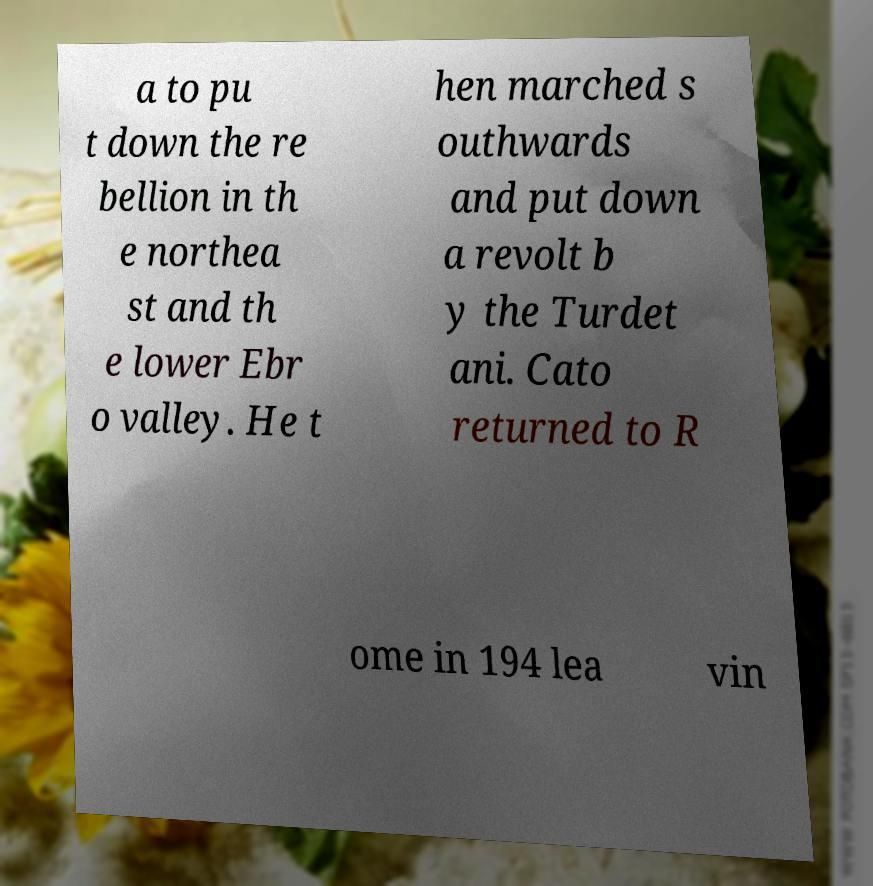For documentation purposes, I need the text within this image transcribed. Could you provide that? a to pu t down the re bellion in th e northea st and th e lower Ebr o valley. He t hen marched s outhwards and put down a revolt b y the Turdet ani. Cato returned to R ome in 194 lea vin 